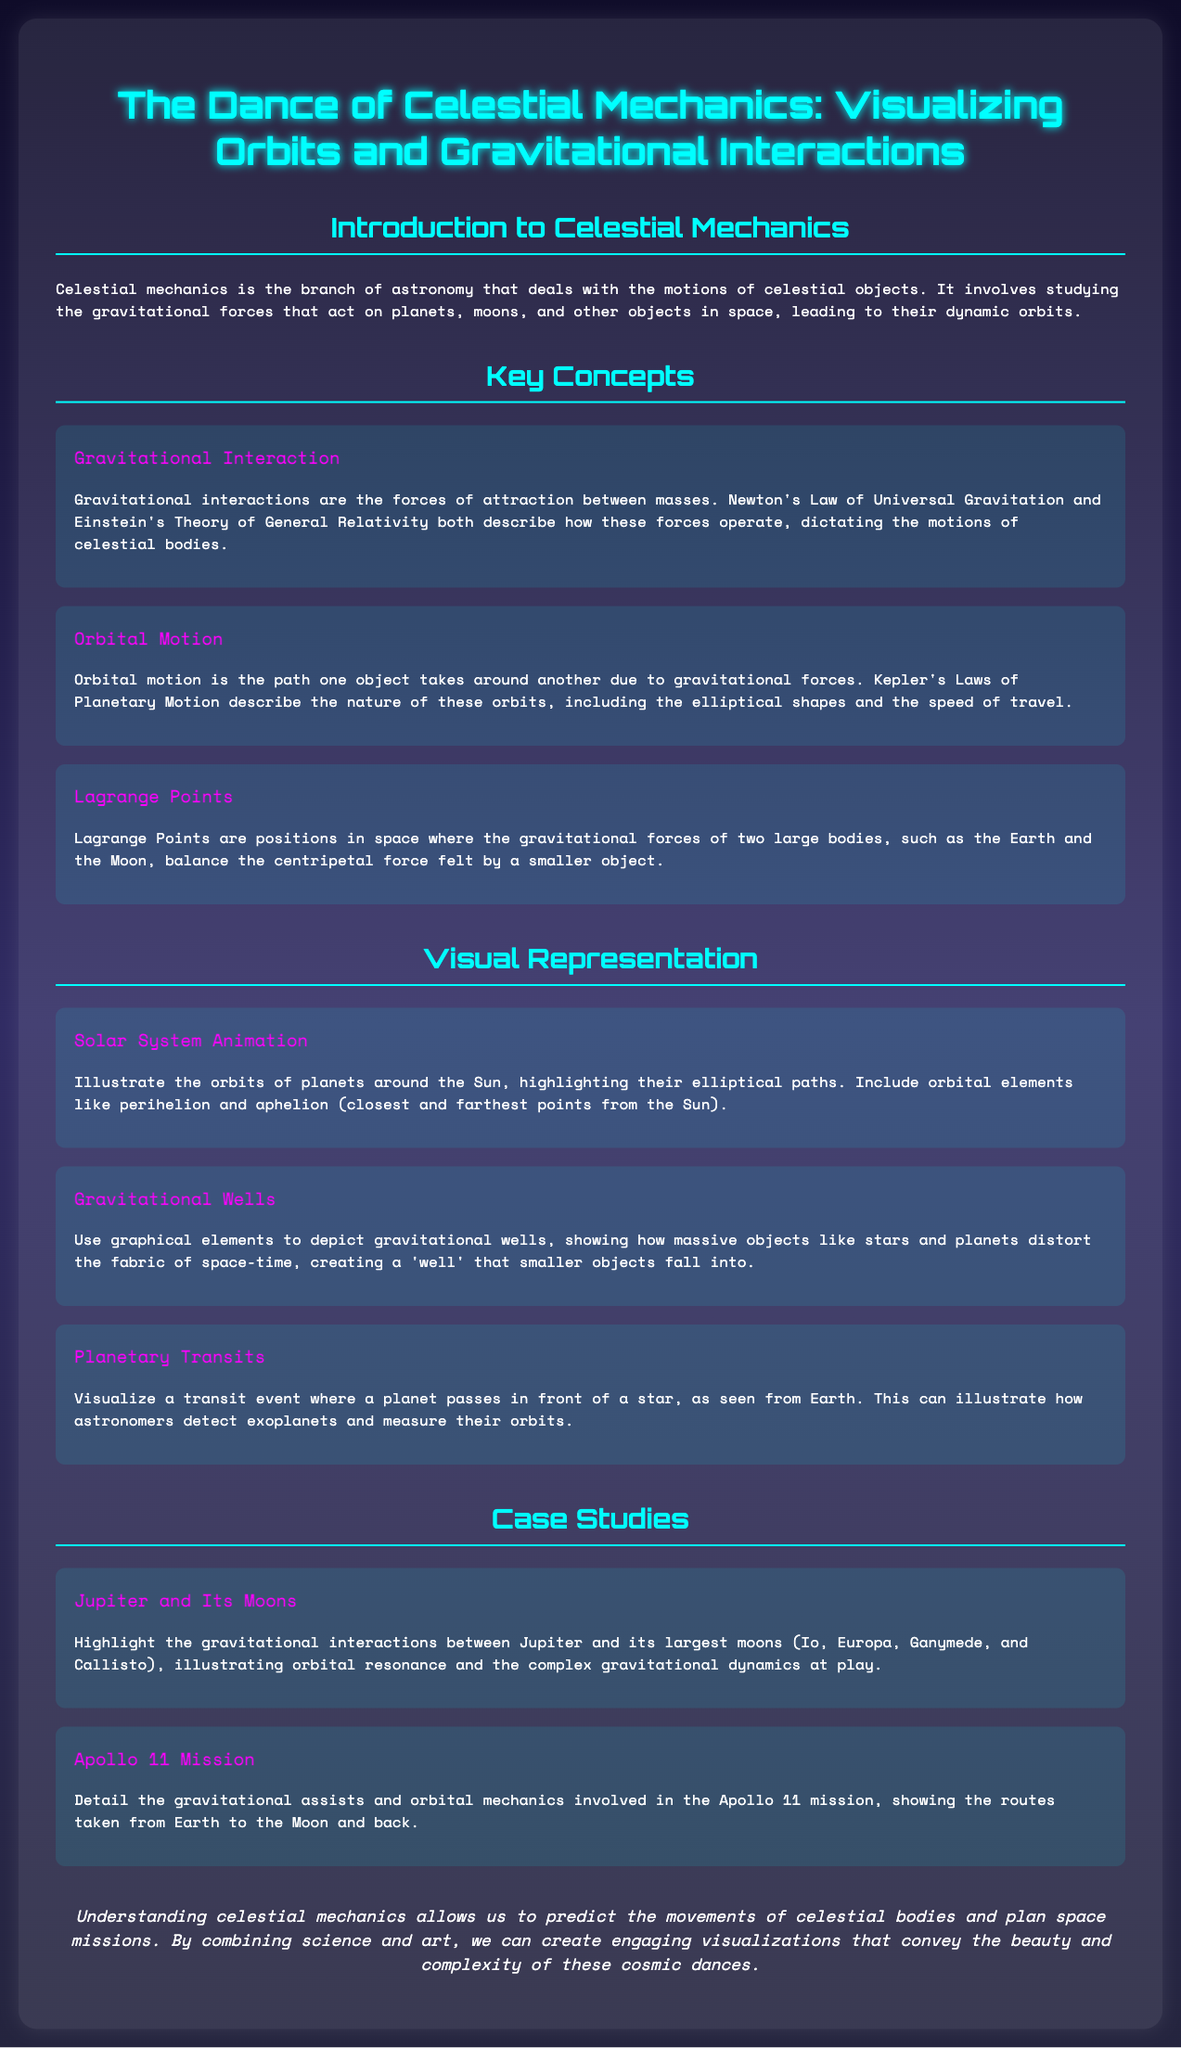What is the title of the infographic? The title of the infographic is provided at the top of the document and summarizes its main focus on celestial mechanics.
Answer: The Dance of Celestial Mechanics: Visualizing Orbits and Gravitational Interactions What are Kepler's Laws related to? Kepler's Laws describe the nature of orbital motion, including the specific characteristics of how celestial bodies move in their orbits.
Answer: Orbital motion What is the purpose of Lagrange Points? Lagrange Points serve as positions where gravitational forces balance, allowing smaller objects to maintain a stable position in relation to larger bodies.
Answer: Balance of gravitational forces Which mission is detailed as a case study in the document? The document includes a specific historical mission relating to space exploration to illustrate gravitational assists and orbital mechanics.
Answer: Apollo 11 Mission What graphical element depicts how massive objects distort space-time? The document discusses a specific visual representation that highlights the effect of gravity on the fabric of space-time.
Answer: Gravitational Wells How many major moons of Jupiter are mentioned in the case study? The case study focuses on Jupiter's gravitational interactions with its largest moons, prompting an inquiry into their number.
Answer: Four What color is primarily used for headings in the document? The color scheme of the infographic is identified through its headings, which adhere to a consistent design choice.
Answer: Cyan What is the concluding message about blending art and science? The conclusion emphasizes the importance of integrating artistic visualization with scientific understanding in celestial mechanics.
Answer: Beauty and complexity 